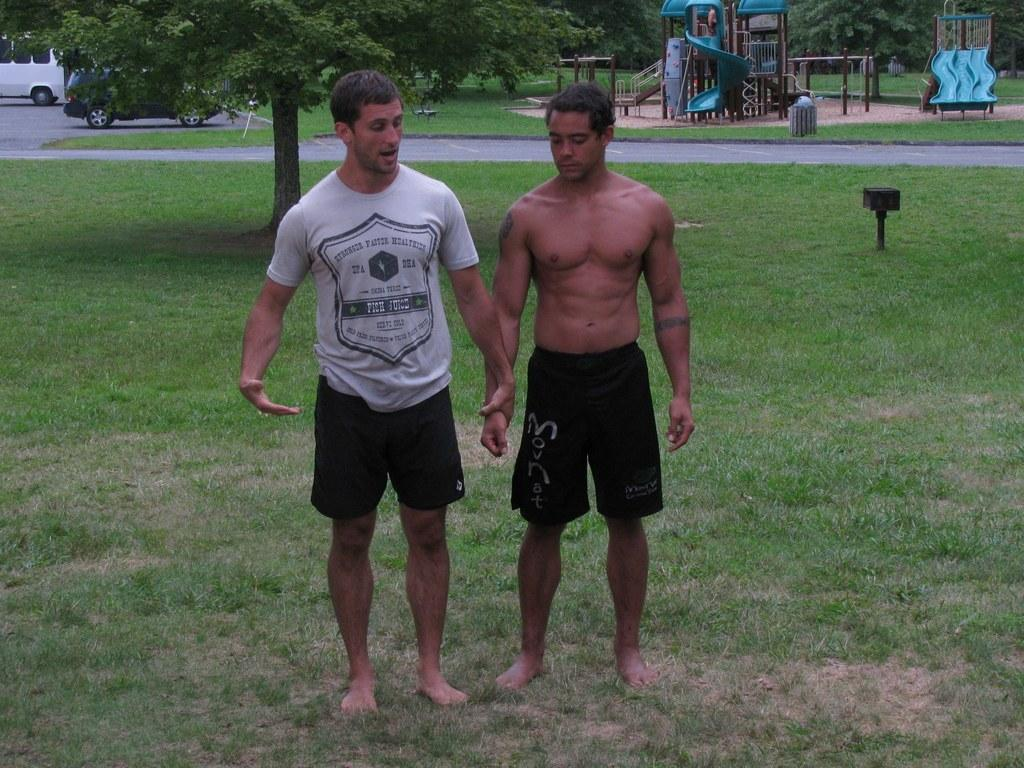How many people are in the center of the image? There are two men in the center of the image. What is the terrain like where the men are located? The men are on a grassland. What type of vegetation can be seen in the image? There are trees in the image. What else can be seen in the image besides the men and trees? There are cars and slides in the image. What type of record can be seen in the hands of one of the men in the image? There is no record present in the image; the men are not holding any objects. 